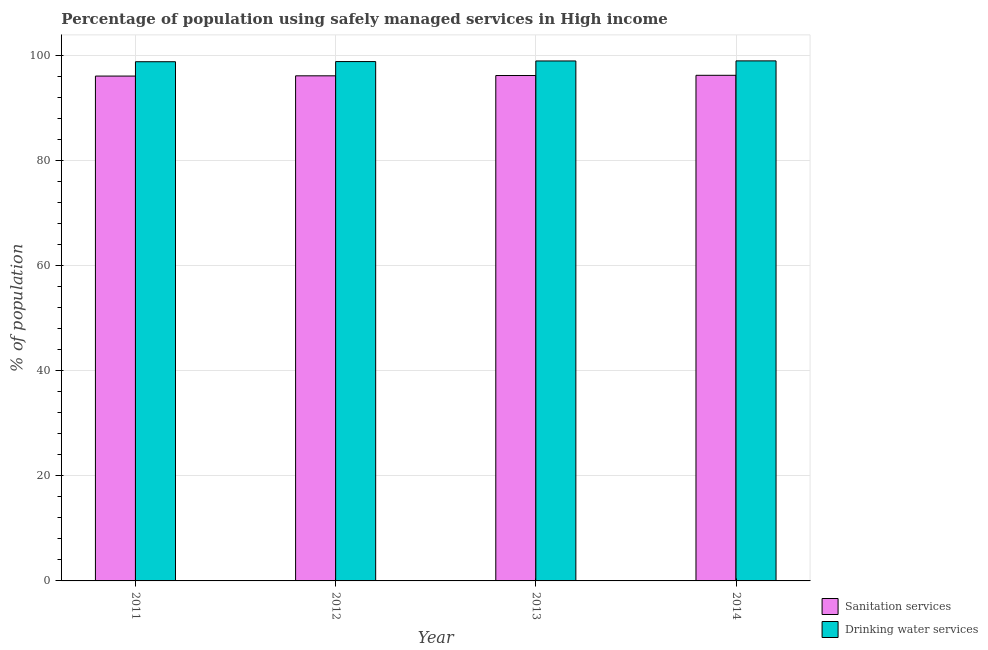Are the number of bars per tick equal to the number of legend labels?
Ensure brevity in your answer.  Yes. How many bars are there on the 2nd tick from the left?
Your answer should be very brief. 2. In how many cases, is the number of bars for a given year not equal to the number of legend labels?
Your response must be concise. 0. What is the percentage of population who used drinking water services in 2014?
Ensure brevity in your answer.  99.04. Across all years, what is the maximum percentage of population who used drinking water services?
Ensure brevity in your answer.  99.04. Across all years, what is the minimum percentage of population who used drinking water services?
Your answer should be compact. 98.88. In which year was the percentage of population who used drinking water services maximum?
Your answer should be very brief. 2014. In which year was the percentage of population who used drinking water services minimum?
Give a very brief answer. 2011. What is the total percentage of population who used drinking water services in the graph?
Give a very brief answer. 395.86. What is the difference between the percentage of population who used drinking water services in 2011 and that in 2012?
Provide a short and direct response. -0.03. What is the difference between the percentage of population who used drinking water services in 2013 and the percentage of population who used sanitation services in 2012?
Keep it short and to the point. 0.12. What is the average percentage of population who used sanitation services per year?
Ensure brevity in your answer.  96.22. In how many years, is the percentage of population who used sanitation services greater than 64 %?
Give a very brief answer. 4. What is the ratio of the percentage of population who used drinking water services in 2012 to that in 2013?
Make the answer very short. 1. What is the difference between the highest and the second highest percentage of population who used sanitation services?
Provide a short and direct response. 0.04. What is the difference between the highest and the lowest percentage of population who used drinking water services?
Ensure brevity in your answer.  0.16. In how many years, is the percentage of population who used drinking water services greater than the average percentage of population who used drinking water services taken over all years?
Your answer should be compact. 2. What does the 2nd bar from the left in 2012 represents?
Make the answer very short. Drinking water services. What does the 1st bar from the right in 2013 represents?
Give a very brief answer. Drinking water services. How many bars are there?
Ensure brevity in your answer.  8. Are all the bars in the graph horizontal?
Your answer should be very brief. No. Are the values on the major ticks of Y-axis written in scientific E-notation?
Offer a very short reply. No. Does the graph contain grids?
Your response must be concise. Yes. How many legend labels are there?
Provide a succinct answer. 2. How are the legend labels stacked?
Keep it short and to the point. Vertical. What is the title of the graph?
Your response must be concise. Percentage of population using safely managed services in High income. Does "Passenger Transport Items" appear as one of the legend labels in the graph?
Your response must be concise. No. What is the label or title of the Y-axis?
Your answer should be compact. % of population. What is the % of population of Sanitation services in 2011?
Offer a terse response. 96.15. What is the % of population in Drinking water services in 2011?
Give a very brief answer. 98.88. What is the % of population in Sanitation services in 2012?
Your answer should be compact. 96.2. What is the % of population in Drinking water services in 2012?
Offer a terse response. 98.91. What is the % of population in Sanitation services in 2013?
Offer a very short reply. 96.26. What is the % of population in Drinking water services in 2013?
Offer a terse response. 99.03. What is the % of population in Sanitation services in 2014?
Your response must be concise. 96.3. What is the % of population of Drinking water services in 2014?
Make the answer very short. 99.04. Across all years, what is the maximum % of population of Sanitation services?
Keep it short and to the point. 96.3. Across all years, what is the maximum % of population of Drinking water services?
Offer a terse response. 99.04. Across all years, what is the minimum % of population in Sanitation services?
Provide a succinct answer. 96.15. Across all years, what is the minimum % of population in Drinking water services?
Your answer should be very brief. 98.88. What is the total % of population of Sanitation services in the graph?
Your answer should be very brief. 384.9. What is the total % of population in Drinking water services in the graph?
Ensure brevity in your answer.  395.86. What is the difference between the % of population in Sanitation services in 2011 and that in 2012?
Offer a very short reply. -0.05. What is the difference between the % of population in Drinking water services in 2011 and that in 2012?
Offer a terse response. -0.03. What is the difference between the % of population in Sanitation services in 2011 and that in 2013?
Provide a succinct answer. -0.11. What is the difference between the % of population of Drinking water services in 2011 and that in 2013?
Your answer should be compact. -0.15. What is the difference between the % of population of Sanitation services in 2011 and that in 2014?
Give a very brief answer. -0.15. What is the difference between the % of population in Drinking water services in 2011 and that in 2014?
Offer a very short reply. -0.16. What is the difference between the % of population of Sanitation services in 2012 and that in 2013?
Keep it short and to the point. -0.06. What is the difference between the % of population in Drinking water services in 2012 and that in 2013?
Your answer should be compact. -0.12. What is the difference between the % of population of Sanitation services in 2012 and that in 2014?
Make the answer very short. -0.1. What is the difference between the % of population of Drinking water services in 2012 and that in 2014?
Offer a terse response. -0.13. What is the difference between the % of population in Sanitation services in 2013 and that in 2014?
Offer a terse response. -0.04. What is the difference between the % of population of Drinking water services in 2013 and that in 2014?
Your answer should be compact. -0.02. What is the difference between the % of population in Sanitation services in 2011 and the % of population in Drinking water services in 2012?
Your answer should be very brief. -2.76. What is the difference between the % of population in Sanitation services in 2011 and the % of population in Drinking water services in 2013?
Keep it short and to the point. -2.88. What is the difference between the % of population of Sanitation services in 2011 and the % of population of Drinking water services in 2014?
Give a very brief answer. -2.89. What is the difference between the % of population in Sanitation services in 2012 and the % of population in Drinking water services in 2013?
Your response must be concise. -2.83. What is the difference between the % of population in Sanitation services in 2012 and the % of population in Drinking water services in 2014?
Keep it short and to the point. -2.85. What is the difference between the % of population in Sanitation services in 2013 and the % of population in Drinking water services in 2014?
Offer a very short reply. -2.79. What is the average % of population in Sanitation services per year?
Your answer should be compact. 96.22. What is the average % of population of Drinking water services per year?
Give a very brief answer. 98.97. In the year 2011, what is the difference between the % of population in Sanitation services and % of population in Drinking water services?
Your answer should be very brief. -2.73. In the year 2012, what is the difference between the % of population of Sanitation services and % of population of Drinking water services?
Keep it short and to the point. -2.71. In the year 2013, what is the difference between the % of population in Sanitation services and % of population in Drinking water services?
Your response must be concise. -2.77. In the year 2014, what is the difference between the % of population of Sanitation services and % of population of Drinking water services?
Offer a very short reply. -2.75. What is the ratio of the % of population in Drinking water services in 2011 to that in 2013?
Keep it short and to the point. 1. What is the ratio of the % of population of Sanitation services in 2011 to that in 2014?
Your response must be concise. 1. What is the ratio of the % of population in Sanitation services in 2012 to that in 2013?
Provide a succinct answer. 1. What is the ratio of the % of population of Sanitation services in 2012 to that in 2014?
Keep it short and to the point. 1. What is the ratio of the % of population in Drinking water services in 2012 to that in 2014?
Your answer should be very brief. 1. What is the ratio of the % of population of Sanitation services in 2013 to that in 2014?
Ensure brevity in your answer.  1. What is the ratio of the % of population of Drinking water services in 2013 to that in 2014?
Offer a terse response. 1. What is the difference between the highest and the second highest % of population in Sanitation services?
Offer a terse response. 0.04. What is the difference between the highest and the second highest % of population of Drinking water services?
Offer a very short reply. 0.02. What is the difference between the highest and the lowest % of population in Sanitation services?
Your response must be concise. 0.15. What is the difference between the highest and the lowest % of population in Drinking water services?
Keep it short and to the point. 0.16. 